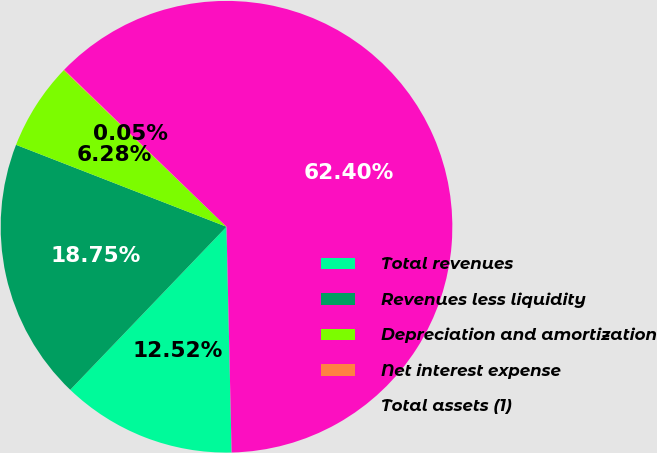<chart> <loc_0><loc_0><loc_500><loc_500><pie_chart><fcel>Total revenues<fcel>Revenues less liquidity<fcel>Depreciation and amortization<fcel>Net interest expense<fcel>Total assets (1)<nl><fcel>12.52%<fcel>18.75%<fcel>6.28%<fcel>0.05%<fcel>62.4%<nl></chart> 